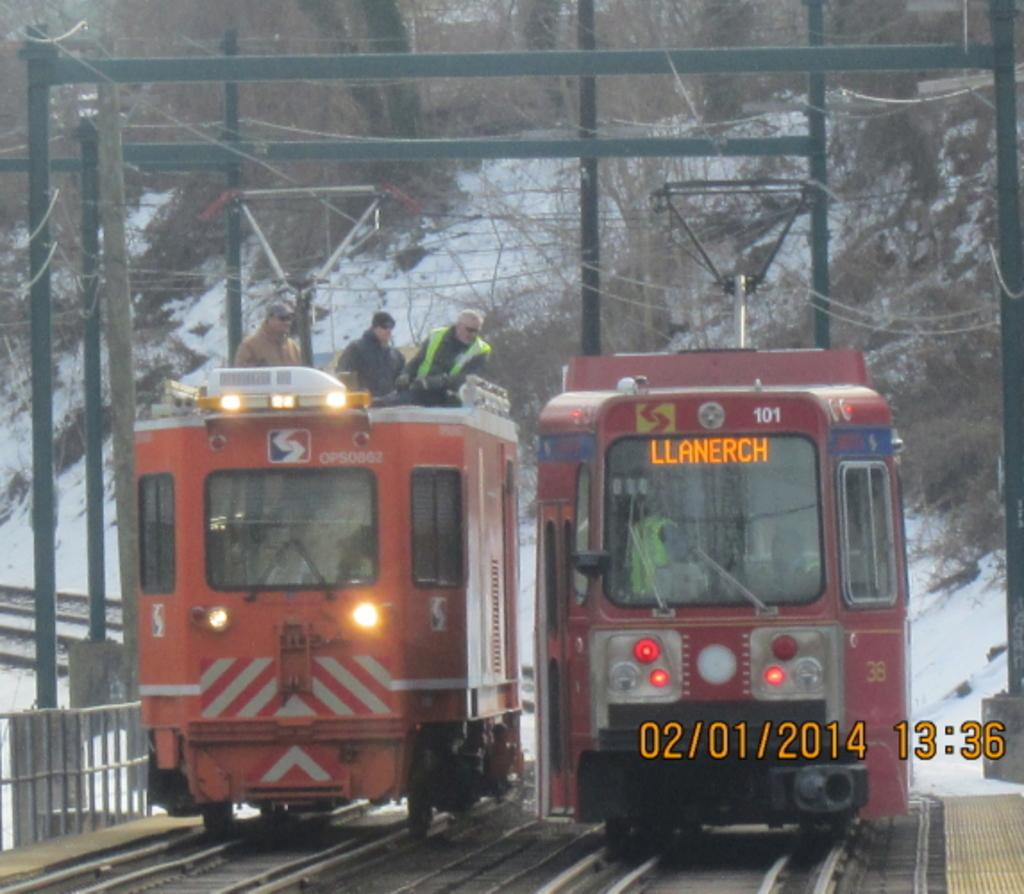<image>
Give a short and clear explanation of the subsequent image. Two trains moving next to each other, one is heading to Llanerch 